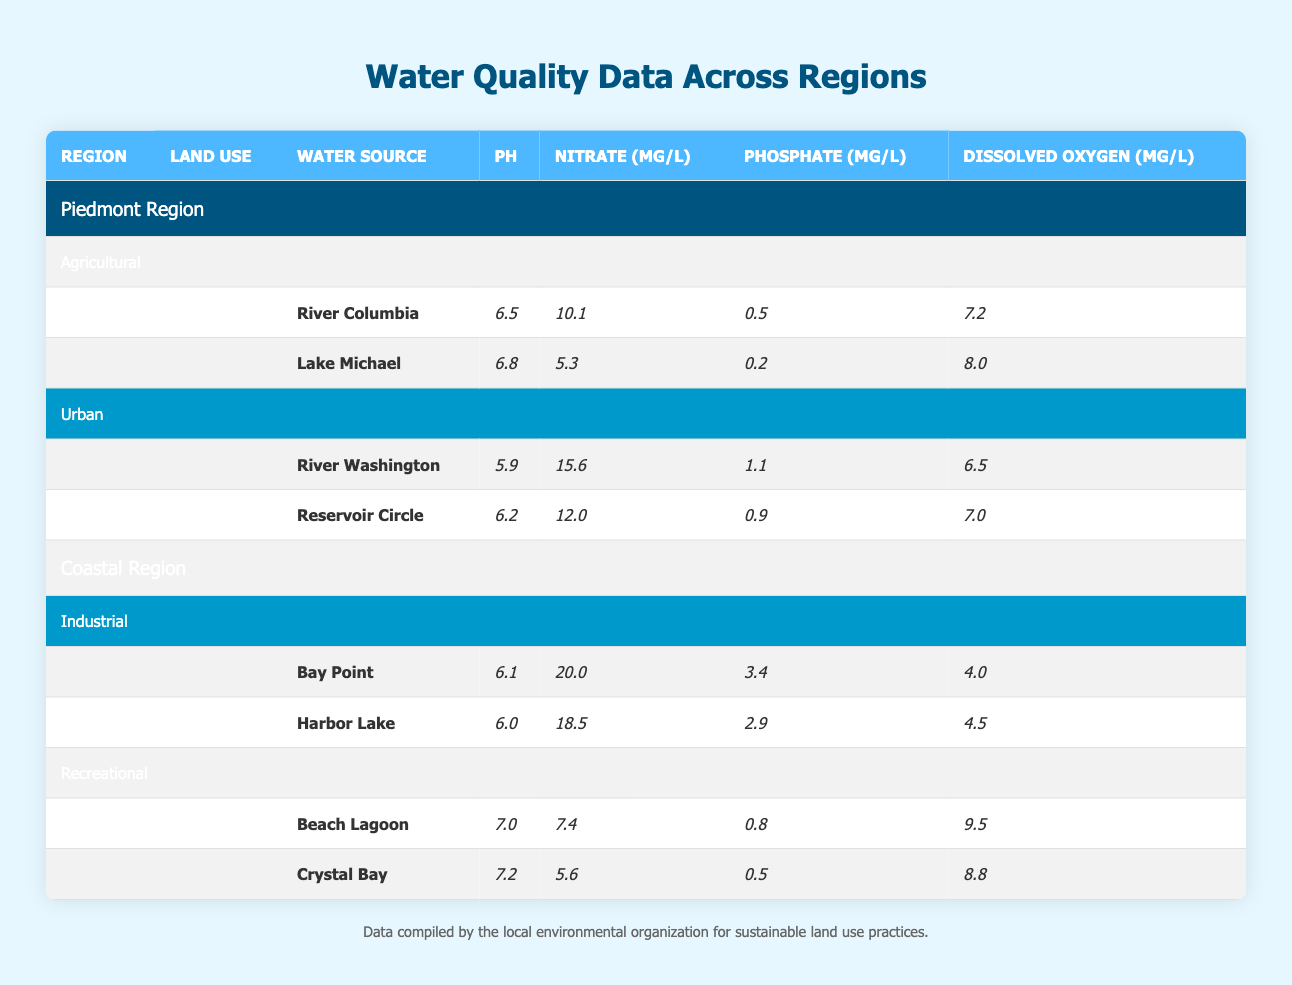What is the pH of the River Columbia? The table lists the pH value for the River Columbia under the Agricultural land use in the Piedmont Region, which is directly provided as 6.5.
Answer: 6.5 What is the concentration of Nitrate in Harbor Lake? The table indicates the Nitrate concentration for Harbor Lake under the Industrial land use in the Coastal Region, which is shown as 18.5 mg/L.
Answer: 18.5 mg/L Is the pH of Lake Michael higher than that of Reservoir Circle? The pH of Lake Michael is 6.8, and the pH of Reservoir Circle is 6.2. Since 6.8 is greater than 6.2, the statement is true.
Answer: Yes What is the average concentration of Phosphate among all water sources in the Coastal Region? The Phosphate values are 3.4 (Bay Point), 2.9 (Harbor Lake), 0.8 (Beach Lagoon), and 0.5 (Crystal Bay). The total Phosphate is 3.4 + 2.9 + 0.8 + 0.5 = 8.6, and there are 4 sources. Thus, the average is 8.6 / 4 = 2.15.
Answer: 2.15 mg/L Which land use has the highest Nitrate concentration among all the sources listed? The Nitrate concentrations are as follows: Agricultural (10.1, 5.3), Urban (15.6, 12.0), Industrial (20.0, 18.5), and Recreational (7.4, 5.6). The highest value is 20.0 mg/L in Bay Point under Industrial land use.
Answer: Industrial Which water source has the highest Dissolved Oxygen level? The Dissolved Oxygen values are 7.2 (River Columbia), 8.0 (Lake Michael), 6.5 (River Washington), 7.0 (Reservoir Circle), 4.0 (Bay Point), 4.5 (Harbor Lake), 9.5 (Beach Lagoon), and 8.8 (Crystal Bay). The highest value is 9.5 mg/L in Beach Lagoon.
Answer: Beach Lagoon Is the Nitrate concentration in Urban land uses higher than that in Agricultural land uses? The Nitrate concentration in Urban land uses is 15.6 mg/L (River Washington) and 12.0 mg/L (Reservoir Circle), which sum to 27.6 mg/L. The Agricultural land uses show concentrations of 10.1 mg/L (River Columbia) and 5.3 mg/L (Lake Michael), summing to 15.4 mg/L. Therefore, Urban land uses have a higher concentration.
Answer: Yes What is the difference in pH between the highest and lowest water source in the Piedmont Region? In the Piedmont Region, the highest pH is 6.8 (Lake Michael) and the lowest is 5.9 (River Washington). The difference is 6.8 - 5.9 = 0.9.
Answer: 0.9 Which region shows a higher average pH level when comparing all water sources? For the Piedmont Region, the pH levels are 6.5, 6.8, 5.9, and 6.2, leading to an average pH of (6.5 + 6.8 + 5.9 + 6.2) / 4 = 6.35. For the Coastal Region, the values are 6.1, 6.0, 7.0, and 7.2, resulting in an average of (6.1 + 6.0 + 7.0 + 7.2) / 4 = 6.58. Thus, the Coastal Region has a higher average pH level.
Answer: Coastal Region 